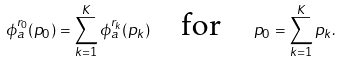<formula> <loc_0><loc_0><loc_500><loc_500>\phi _ { a } ^ { r _ { 0 } } ( p _ { 0 } ) = \sum _ { k = 1 } ^ { K } \phi _ { a } ^ { r _ { k } } ( p _ { k } ) \quad \text {for} \quad p _ { 0 } = \sum _ { k = 1 } ^ { K } p _ { k } .</formula> 